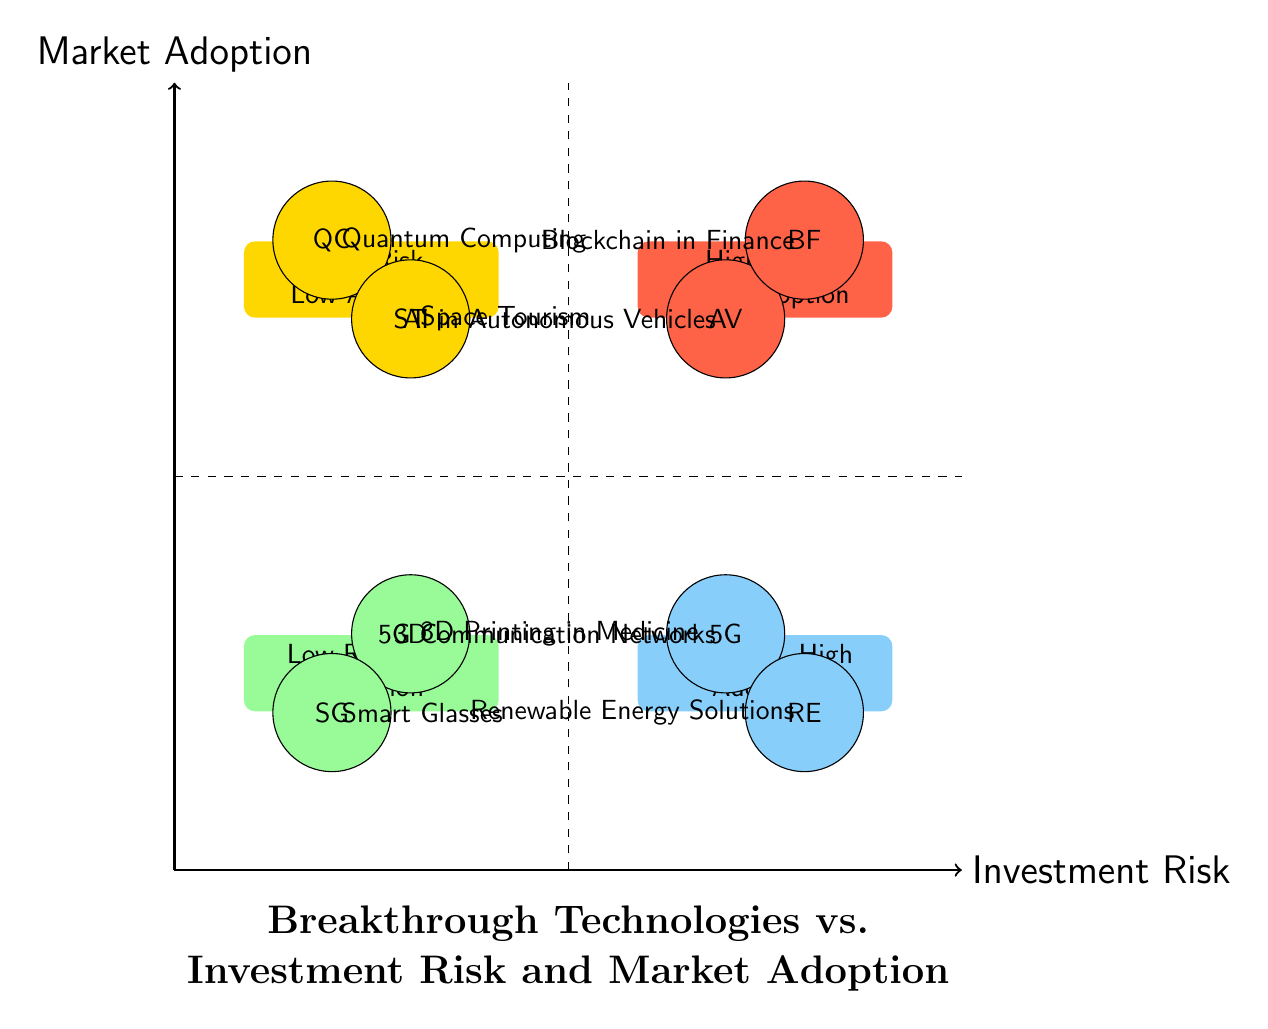What are the technologies in the "High Risk, Low Adoption" quadrant? The "High Risk, Low Adoption" quadrant contains two technologies: Quantum Computing and Space Tourism. These technologies are classified as high risk due to their experimental nature and low adoption rates.
Answer: Quantum Computing, Space Tourism How many technologies are in the "Low Risk, High Adoption" quadrant? There are two technologies present in the "Low Risk, High Adoption" quadrant. This quadrant indicates technologies that are widely adopted and present lower investment risks.
Answer: 2 Which technology represents "Low Risk, Low Adoption"? The technology that represents "Low Risk, Low Adoption" is 3D Printing in Medicine. It shows promise in its field but has not achieved significant market penetration yet.
Answer: 3D Printing in Medicine What is the relationship between AI in Autonomous Vehicles and Blockchain in Finance? Both AI in Autonomous Vehicles and Blockchain in Finance are located in the "High Risk, High Adoption" quadrant, indicating that they carry substantial investment risks while being widely anticipated or adopted in their respective markets.
Answer: High Risk, High Adoption Which quadrant contains Renewable Energy Solutions, and what is its investment risk status? Renewable Energy Solutions is located in the "Low Risk, High Adoption" quadrant. This indicates that it has a strong market presence and offers lower investment risks due to a mature market.
Answer: Low Risk, High Adoption What is common among the technologies in the "Low Risk, Low Adoption" quadrant? The common characteristic among the technologies in the "Low Risk, Low Adoption" quadrant is that they all show potential but have yet to achieve significant market penetration. This reflects a fundamental challenge in their broader acceptance.
Answer: Potential, Low Adoption In which quadrant is Space Tourism located, and what does this imply about market acceptance? Space Tourism is situated in the "High Risk, Low Adoption" quadrant, implying that it faces significant challenges in market acceptance and requires considerable investment to develop, which may not yield immediate returns.
Answer: High Risk, Low Adoption What type of technologies are represented in the "High Risk, High Adoption" quadrant? The technologies represented in the "High Risk, High Adoption" quadrant are AI in Autonomous Vehicles and Blockchain in Finance. These technologies are characterized by both significant investment risks and rising market acceptance.
Answer: AI in Autonomous Vehicles, Blockchain in Finance 